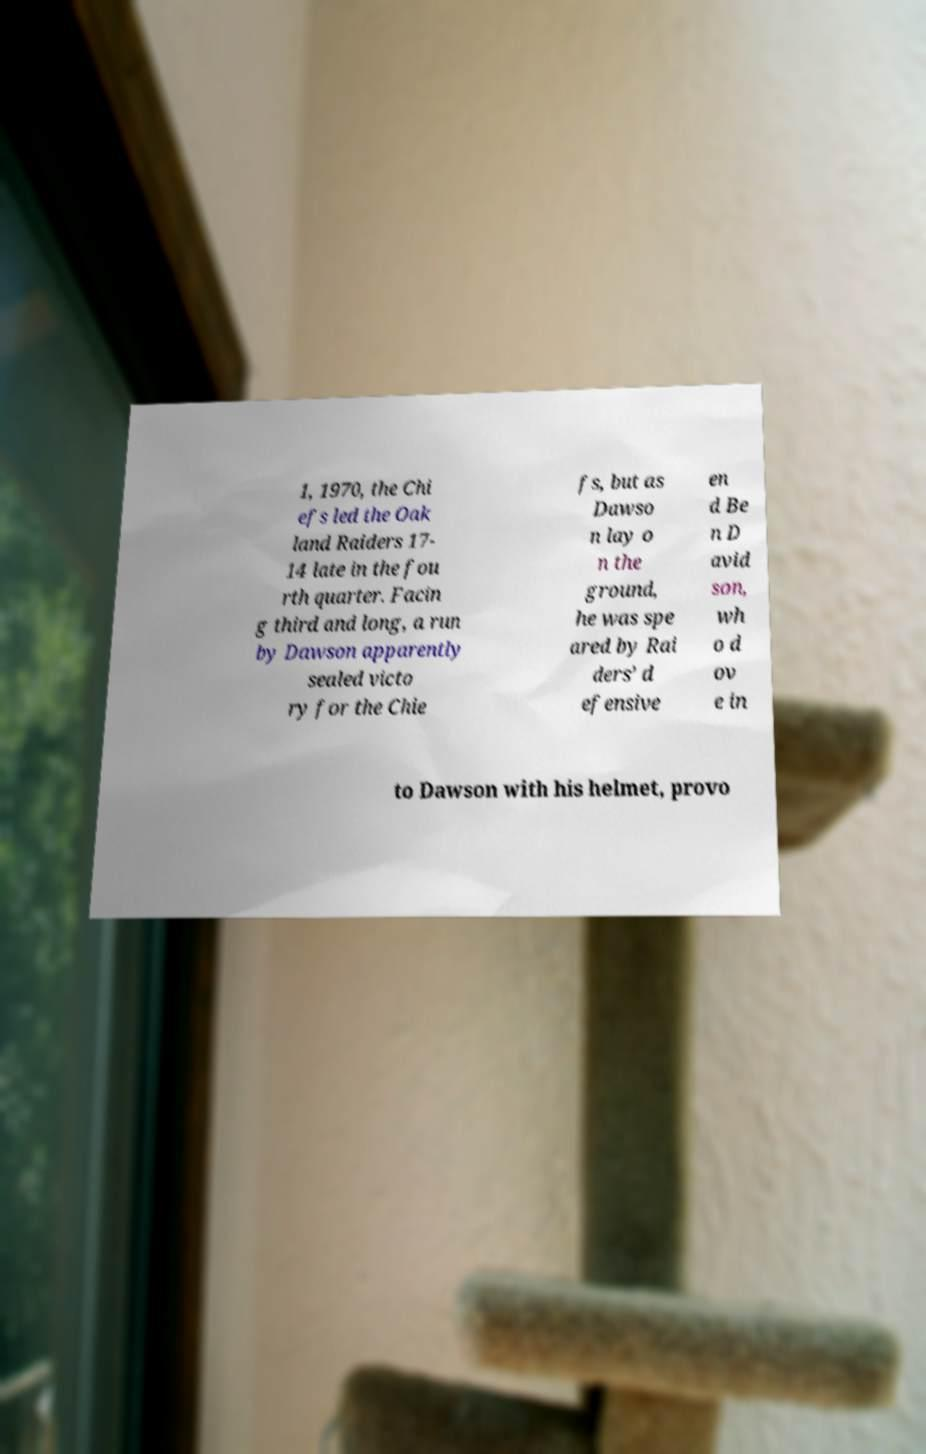Can you read and provide the text displayed in the image?This photo seems to have some interesting text. Can you extract and type it out for me? 1, 1970, the Chi efs led the Oak land Raiders 17- 14 late in the fou rth quarter. Facin g third and long, a run by Dawson apparently sealed victo ry for the Chie fs, but as Dawso n lay o n the ground, he was spe ared by Rai ders’ d efensive en d Be n D avid son, wh o d ov e in to Dawson with his helmet, provo 